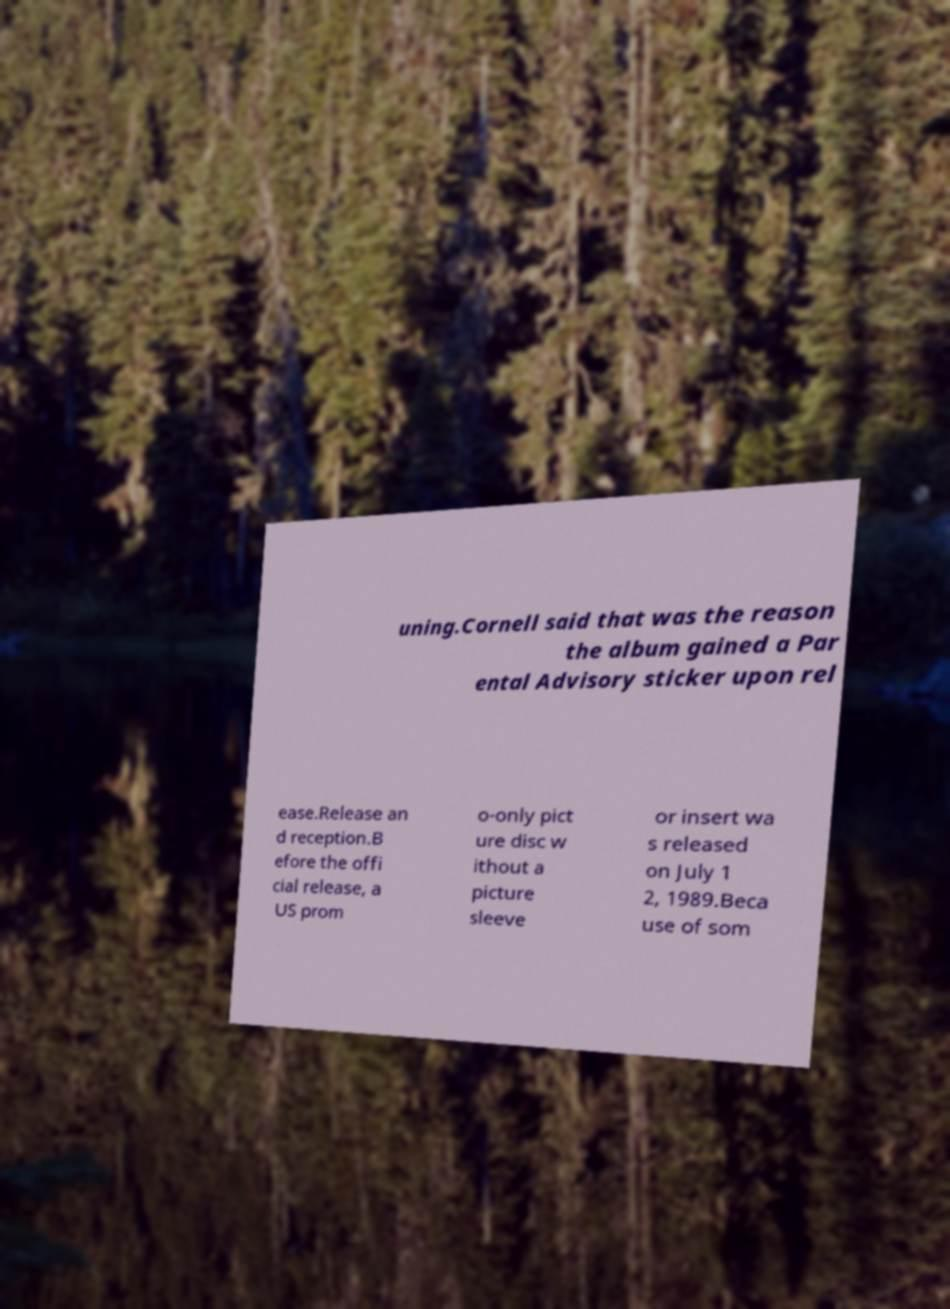There's text embedded in this image that I need extracted. Can you transcribe it verbatim? uning.Cornell said that was the reason the album gained a Par ental Advisory sticker upon rel ease.Release an d reception.B efore the offi cial release, a US prom o-only pict ure disc w ithout a picture sleeve or insert wa s released on July 1 2, 1989.Beca use of som 